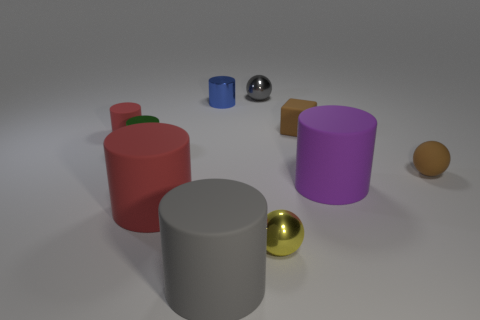Subtract all small metallic spheres. How many spheres are left? 1 Subtract all brown balls. How many balls are left? 2 Subtract all brown cubes. How many red cylinders are left? 2 Subtract all spheres. How many objects are left? 7 Subtract 1 blocks. How many blocks are left? 0 Subtract all gray spheres. Subtract all cyan cubes. How many spheres are left? 2 Subtract all tiny shiny cylinders. Subtract all rubber cubes. How many objects are left? 7 Add 7 purple rubber objects. How many purple rubber objects are left? 8 Add 4 yellow shiny spheres. How many yellow shiny spheres exist? 5 Subtract 0 green spheres. How many objects are left? 10 